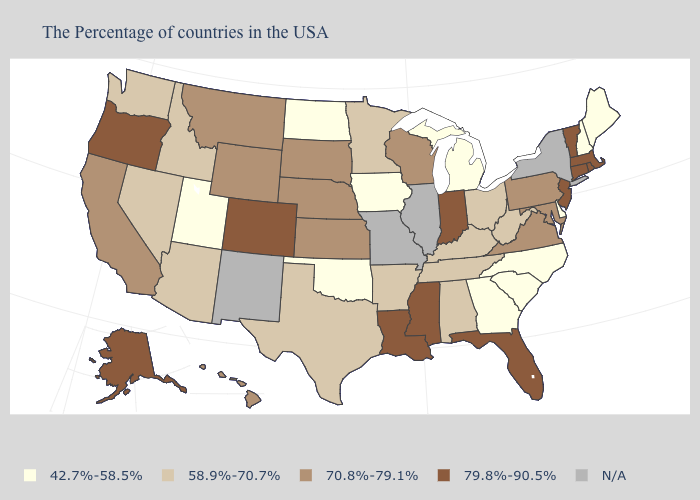Does the map have missing data?
Be succinct. Yes. What is the value of Florida?
Concise answer only. 79.8%-90.5%. Which states have the lowest value in the Northeast?
Answer briefly. Maine, New Hampshire. Does Indiana have the highest value in the MidWest?
Concise answer only. Yes. What is the value of Oregon?
Concise answer only. 79.8%-90.5%. Among the states that border Colorado , does Arizona have the highest value?
Be succinct. No. What is the lowest value in states that border Louisiana?
Short answer required. 58.9%-70.7%. Name the states that have a value in the range 70.8%-79.1%?
Give a very brief answer. Maryland, Pennsylvania, Virginia, Wisconsin, Kansas, Nebraska, South Dakota, Wyoming, Montana, California, Hawaii. Name the states that have a value in the range N/A?
Short answer required. New York, Illinois, Missouri, New Mexico. What is the value of Minnesota?
Keep it brief. 58.9%-70.7%. Name the states that have a value in the range 42.7%-58.5%?
Quick response, please. Maine, New Hampshire, Delaware, North Carolina, South Carolina, Georgia, Michigan, Iowa, Oklahoma, North Dakota, Utah. What is the value of Florida?
Give a very brief answer. 79.8%-90.5%. 